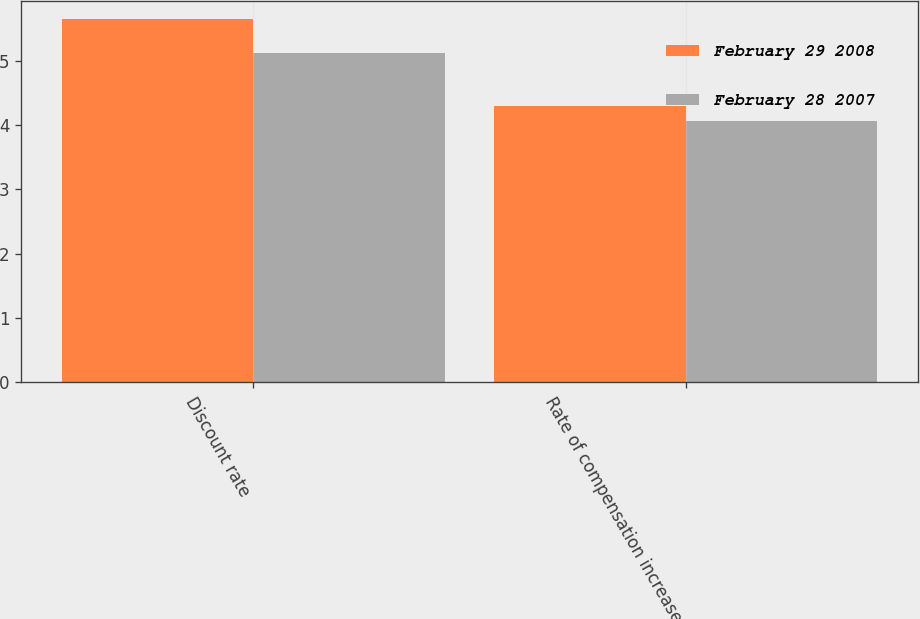Convert chart. <chart><loc_0><loc_0><loc_500><loc_500><stacked_bar_chart><ecel><fcel>Discount rate<fcel>Rate of compensation increase<nl><fcel>February 29 2008<fcel>5.65<fcel>4.3<nl><fcel>February 28 2007<fcel>5.12<fcel>4.07<nl></chart> 